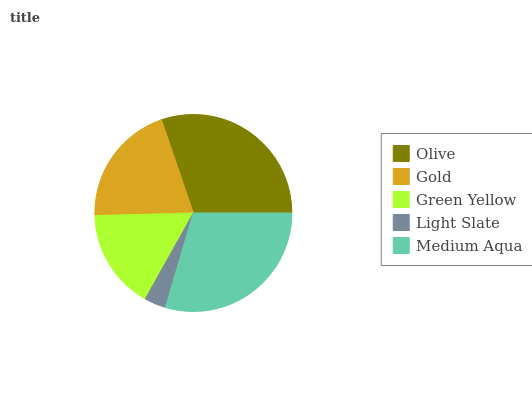Is Light Slate the minimum?
Answer yes or no. Yes. Is Olive the maximum?
Answer yes or no. Yes. Is Gold the minimum?
Answer yes or no. No. Is Gold the maximum?
Answer yes or no. No. Is Olive greater than Gold?
Answer yes or no. Yes. Is Gold less than Olive?
Answer yes or no. Yes. Is Gold greater than Olive?
Answer yes or no. No. Is Olive less than Gold?
Answer yes or no. No. Is Gold the high median?
Answer yes or no. Yes. Is Gold the low median?
Answer yes or no. Yes. Is Green Yellow the high median?
Answer yes or no. No. Is Medium Aqua the low median?
Answer yes or no. No. 